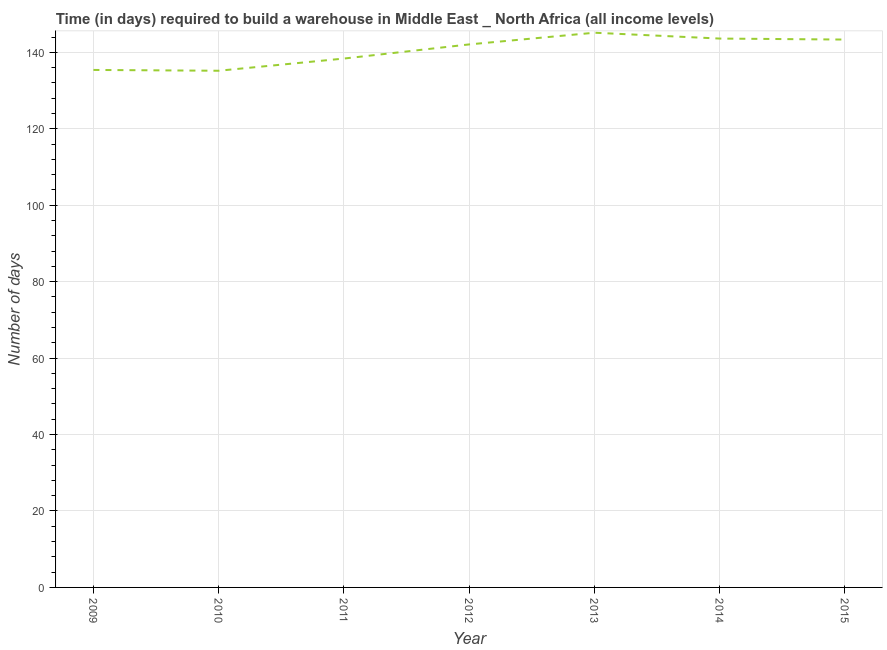What is the time required to build a warehouse in 2014?
Ensure brevity in your answer.  143.61. Across all years, what is the maximum time required to build a warehouse?
Provide a short and direct response. 145.13. Across all years, what is the minimum time required to build a warehouse?
Give a very brief answer. 135.18. In which year was the time required to build a warehouse maximum?
Keep it short and to the point. 2013. In which year was the time required to build a warehouse minimum?
Give a very brief answer. 2010. What is the sum of the time required to build a warehouse?
Offer a terse response. 983.11. What is the difference between the time required to build a warehouse in 2011 and 2012?
Your answer should be compact. -3.7. What is the average time required to build a warehouse per year?
Ensure brevity in your answer.  140.44. What is the median time required to build a warehouse?
Your answer should be very brief. 142.07. Do a majority of the years between 2013 and 2011 (inclusive) have time required to build a warehouse greater than 32 days?
Offer a terse response. No. What is the ratio of the time required to build a warehouse in 2012 to that in 2014?
Provide a succinct answer. 0.99. Is the difference between the time required to build a warehouse in 2011 and 2014 greater than the difference between any two years?
Provide a succinct answer. No. What is the difference between the highest and the second highest time required to build a warehouse?
Your answer should be very brief. 1.53. What is the difference between the highest and the lowest time required to build a warehouse?
Provide a short and direct response. 9.95. In how many years, is the time required to build a warehouse greater than the average time required to build a warehouse taken over all years?
Your answer should be compact. 4. Does the time required to build a warehouse monotonically increase over the years?
Your answer should be compact. No. What is the difference between two consecutive major ticks on the Y-axis?
Ensure brevity in your answer.  20. Does the graph contain any zero values?
Offer a terse response. No. What is the title of the graph?
Keep it short and to the point. Time (in days) required to build a warehouse in Middle East _ North Africa (all income levels). What is the label or title of the X-axis?
Provide a short and direct response. Year. What is the label or title of the Y-axis?
Make the answer very short. Number of days. What is the Number of days of 2009?
Provide a succinct answer. 135.39. What is the Number of days in 2010?
Provide a succinct answer. 135.18. What is the Number of days of 2011?
Give a very brief answer. 138.38. What is the Number of days of 2012?
Your response must be concise. 142.07. What is the Number of days in 2013?
Give a very brief answer. 145.13. What is the Number of days in 2014?
Give a very brief answer. 143.61. What is the Number of days in 2015?
Give a very brief answer. 143.34. What is the difference between the Number of days in 2009 and 2010?
Provide a succinct answer. 0.21. What is the difference between the Number of days in 2009 and 2011?
Provide a short and direct response. -2.98. What is the difference between the Number of days in 2009 and 2012?
Your response must be concise. -6.68. What is the difference between the Number of days in 2009 and 2013?
Provide a succinct answer. -9.74. What is the difference between the Number of days in 2009 and 2014?
Provide a succinct answer. -8.21. What is the difference between the Number of days in 2009 and 2015?
Provide a succinct answer. -7.95. What is the difference between the Number of days in 2010 and 2011?
Your answer should be compact. -3.19. What is the difference between the Number of days in 2010 and 2012?
Give a very brief answer. -6.89. What is the difference between the Number of days in 2010 and 2013?
Provide a short and direct response. -9.95. What is the difference between the Number of days in 2010 and 2014?
Give a very brief answer. -8.42. What is the difference between the Number of days in 2010 and 2015?
Provide a succinct answer. -8.16. What is the difference between the Number of days in 2011 and 2013?
Keep it short and to the point. -6.76. What is the difference between the Number of days in 2011 and 2014?
Offer a terse response. -5.23. What is the difference between the Number of days in 2011 and 2015?
Your response must be concise. -4.97. What is the difference between the Number of days in 2012 and 2013?
Your answer should be very brief. -3.06. What is the difference between the Number of days in 2012 and 2014?
Your answer should be very brief. -1.53. What is the difference between the Number of days in 2012 and 2015?
Offer a very short reply. -1.27. What is the difference between the Number of days in 2013 and 2014?
Provide a short and direct response. 1.53. What is the difference between the Number of days in 2013 and 2015?
Offer a terse response. 1.79. What is the difference between the Number of days in 2014 and 2015?
Give a very brief answer. 0.26. What is the ratio of the Number of days in 2009 to that in 2012?
Your answer should be compact. 0.95. What is the ratio of the Number of days in 2009 to that in 2013?
Ensure brevity in your answer.  0.93. What is the ratio of the Number of days in 2009 to that in 2014?
Your response must be concise. 0.94. What is the ratio of the Number of days in 2009 to that in 2015?
Provide a short and direct response. 0.94. What is the ratio of the Number of days in 2010 to that in 2011?
Your response must be concise. 0.98. What is the ratio of the Number of days in 2010 to that in 2012?
Provide a short and direct response. 0.95. What is the ratio of the Number of days in 2010 to that in 2014?
Your answer should be compact. 0.94. What is the ratio of the Number of days in 2010 to that in 2015?
Ensure brevity in your answer.  0.94. What is the ratio of the Number of days in 2011 to that in 2013?
Provide a short and direct response. 0.95. What is the ratio of the Number of days in 2011 to that in 2014?
Give a very brief answer. 0.96. What is the ratio of the Number of days in 2011 to that in 2015?
Keep it short and to the point. 0.96. What is the ratio of the Number of days in 2012 to that in 2015?
Provide a succinct answer. 0.99. What is the ratio of the Number of days in 2013 to that in 2014?
Your answer should be very brief. 1.01. What is the ratio of the Number of days in 2013 to that in 2015?
Your response must be concise. 1.01. 